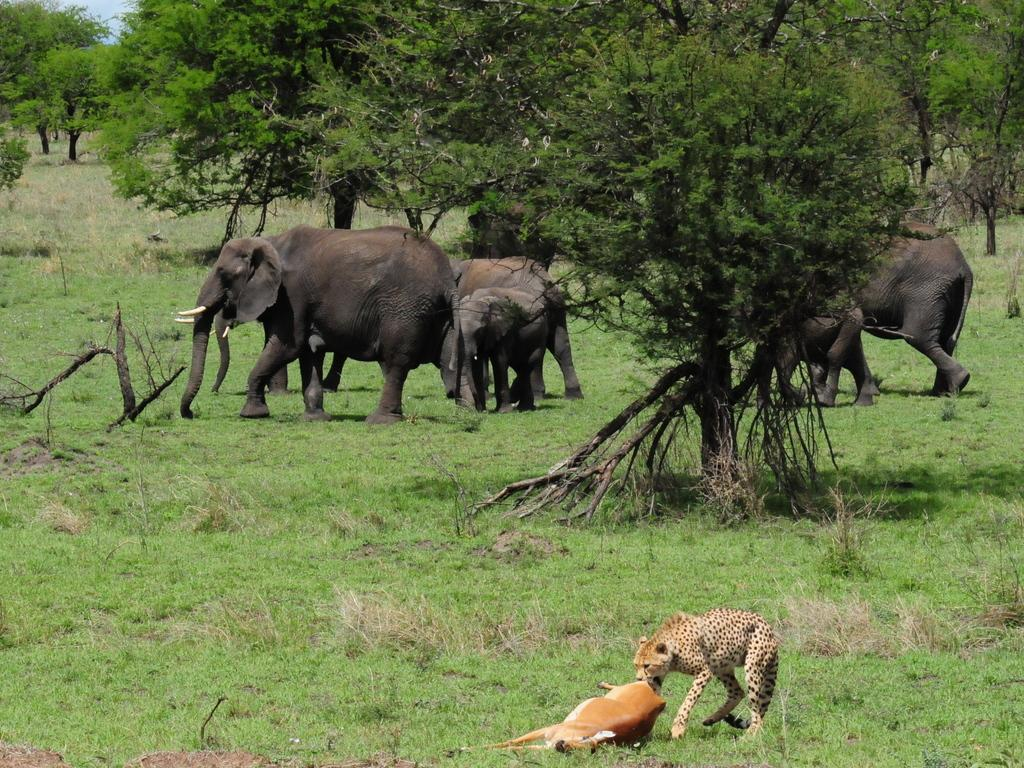What animals can be seen in the image? There are elephants in the image. What are the elephants doing in the image? The elephants are walking on the grassland. What other animal can be seen in the image? There is a cheetah in the image. What is the cheetah doing in the image? The cheetah is eating a deer. What can be seen in the background of the image? There are trees in the background of the image. Where is the oven located in the image? There is no oven present in the image. What type of iron is being used by the elephants in the image? There is no iron present in the image, and the elephants are not using any iron tools. 